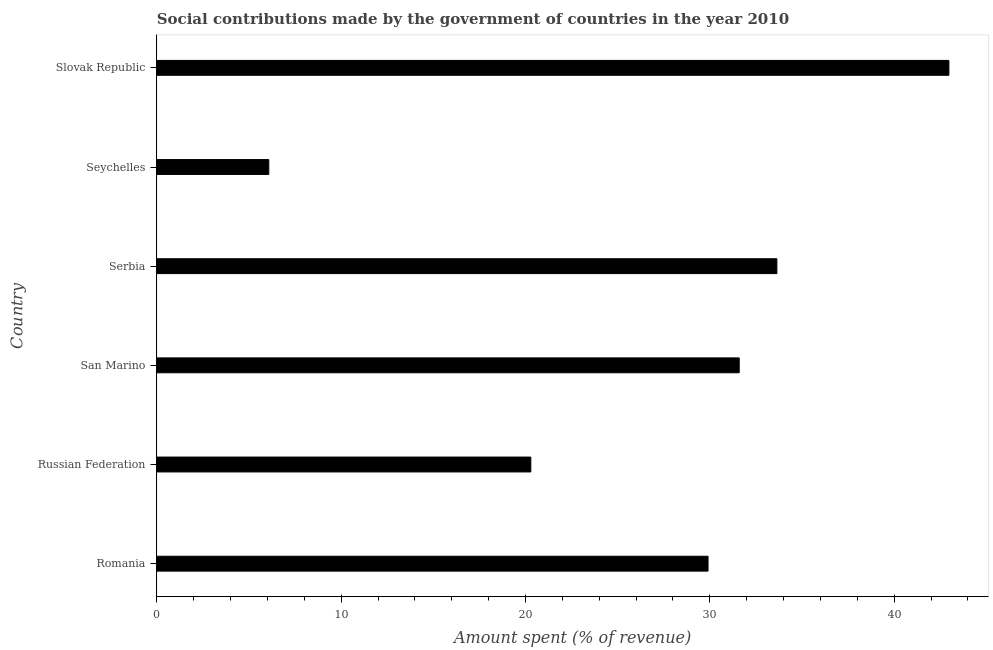Does the graph contain any zero values?
Provide a short and direct response. No. Does the graph contain grids?
Make the answer very short. No. What is the title of the graph?
Give a very brief answer. Social contributions made by the government of countries in the year 2010. What is the label or title of the X-axis?
Your answer should be compact. Amount spent (% of revenue). What is the amount spent in making social contributions in San Marino?
Make the answer very short. 31.59. Across all countries, what is the maximum amount spent in making social contributions?
Your answer should be very brief. 42.97. Across all countries, what is the minimum amount spent in making social contributions?
Your answer should be compact. 6.07. In which country was the amount spent in making social contributions maximum?
Ensure brevity in your answer.  Slovak Republic. In which country was the amount spent in making social contributions minimum?
Keep it short and to the point. Seychelles. What is the sum of the amount spent in making social contributions?
Give a very brief answer. 164.47. What is the difference between the amount spent in making social contributions in Romania and Slovak Republic?
Ensure brevity in your answer.  -13.07. What is the average amount spent in making social contributions per country?
Your response must be concise. 27.41. What is the median amount spent in making social contributions?
Your answer should be compact. 30.75. What is the ratio of the amount spent in making social contributions in Russian Federation to that in Slovak Republic?
Provide a short and direct response. 0.47. What is the difference between the highest and the second highest amount spent in making social contributions?
Give a very brief answer. 9.33. What is the difference between the highest and the lowest amount spent in making social contributions?
Your answer should be very brief. 36.9. How many bars are there?
Ensure brevity in your answer.  6. Are all the bars in the graph horizontal?
Your answer should be very brief. Yes. What is the Amount spent (% of revenue) in Romania?
Keep it short and to the point. 29.9. What is the Amount spent (% of revenue) of Russian Federation?
Provide a succinct answer. 20.29. What is the Amount spent (% of revenue) of San Marino?
Your answer should be compact. 31.59. What is the Amount spent (% of revenue) of Serbia?
Provide a short and direct response. 33.64. What is the Amount spent (% of revenue) in Seychelles?
Make the answer very short. 6.07. What is the Amount spent (% of revenue) in Slovak Republic?
Keep it short and to the point. 42.97. What is the difference between the Amount spent (% of revenue) in Romania and Russian Federation?
Give a very brief answer. 9.61. What is the difference between the Amount spent (% of revenue) in Romania and San Marino?
Provide a short and direct response. -1.69. What is the difference between the Amount spent (% of revenue) in Romania and Serbia?
Offer a terse response. -3.73. What is the difference between the Amount spent (% of revenue) in Romania and Seychelles?
Your response must be concise. 23.83. What is the difference between the Amount spent (% of revenue) in Romania and Slovak Republic?
Offer a very short reply. -13.07. What is the difference between the Amount spent (% of revenue) in Russian Federation and San Marino?
Ensure brevity in your answer.  -11.31. What is the difference between the Amount spent (% of revenue) in Russian Federation and Serbia?
Offer a terse response. -13.35. What is the difference between the Amount spent (% of revenue) in Russian Federation and Seychelles?
Give a very brief answer. 14.22. What is the difference between the Amount spent (% of revenue) in Russian Federation and Slovak Republic?
Give a very brief answer. -22.68. What is the difference between the Amount spent (% of revenue) in San Marino and Serbia?
Provide a succinct answer. -2.04. What is the difference between the Amount spent (% of revenue) in San Marino and Seychelles?
Give a very brief answer. 25.52. What is the difference between the Amount spent (% of revenue) in San Marino and Slovak Republic?
Keep it short and to the point. -11.37. What is the difference between the Amount spent (% of revenue) in Serbia and Seychelles?
Keep it short and to the point. 27.57. What is the difference between the Amount spent (% of revenue) in Serbia and Slovak Republic?
Your answer should be compact. -9.33. What is the difference between the Amount spent (% of revenue) in Seychelles and Slovak Republic?
Keep it short and to the point. -36.9. What is the ratio of the Amount spent (% of revenue) in Romania to that in Russian Federation?
Provide a succinct answer. 1.47. What is the ratio of the Amount spent (% of revenue) in Romania to that in San Marino?
Give a very brief answer. 0.95. What is the ratio of the Amount spent (% of revenue) in Romania to that in Serbia?
Provide a succinct answer. 0.89. What is the ratio of the Amount spent (% of revenue) in Romania to that in Seychelles?
Offer a terse response. 4.92. What is the ratio of the Amount spent (% of revenue) in Romania to that in Slovak Republic?
Your response must be concise. 0.7. What is the ratio of the Amount spent (% of revenue) in Russian Federation to that in San Marino?
Provide a short and direct response. 0.64. What is the ratio of the Amount spent (% of revenue) in Russian Federation to that in Serbia?
Provide a succinct answer. 0.6. What is the ratio of the Amount spent (% of revenue) in Russian Federation to that in Seychelles?
Your answer should be compact. 3.34. What is the ratio of the Amount spent (% of revenue) in Russian Federation to that in Slovak Republic?
Keep it short and to the point. 0.47. What is the ratio of the Amount spent (% of revenue) in San Marino to that in Serbia?
Provide a short and direct response. 0.94. What is the ratio of the Amount spent (% of revenue) in San Marino to that in Seychelles?
Offer a terse response. 5.2. What is the ratio of the Amount spent (% of revenue) in San Marino to that in Slovak Republic?
Your answer should be compact. 0.73. What is the ratio of the Amount spent (% of revenue) in Serbia to that in Seychelles?
Keep it short and to the point. 5.54. What is the ratio of the Amount spent (% of revenue) in Serbia to that in Slovak Republic?
Give a very brief answer. 0.78. What is the ratio of the Amount spent (% of revenue) in Seychelles to that in Slovak Republic?
Keep it short and to the point. 0.14. 